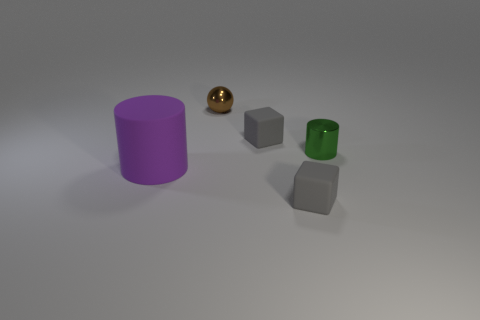Add 2 metallic cylinders. How many objects exist? 7 Subtract all balls. How many objects are left? 4 Add 2 spheres. How many spheres exist? 3 Subtract 0 red cubes. How many objects are left? 5 Subtract all big gray blocks. Subtract all purple things. How many objects are left? 4 Add 5 cylinders. How many cylinders are left? 7 